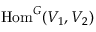Convert formula to latex. <formula><loc_0><loc_0><loc_500><loc_500>{ H o m } ^ { G } ( V _ { 1 } , V _ { 2 } )</formula> 